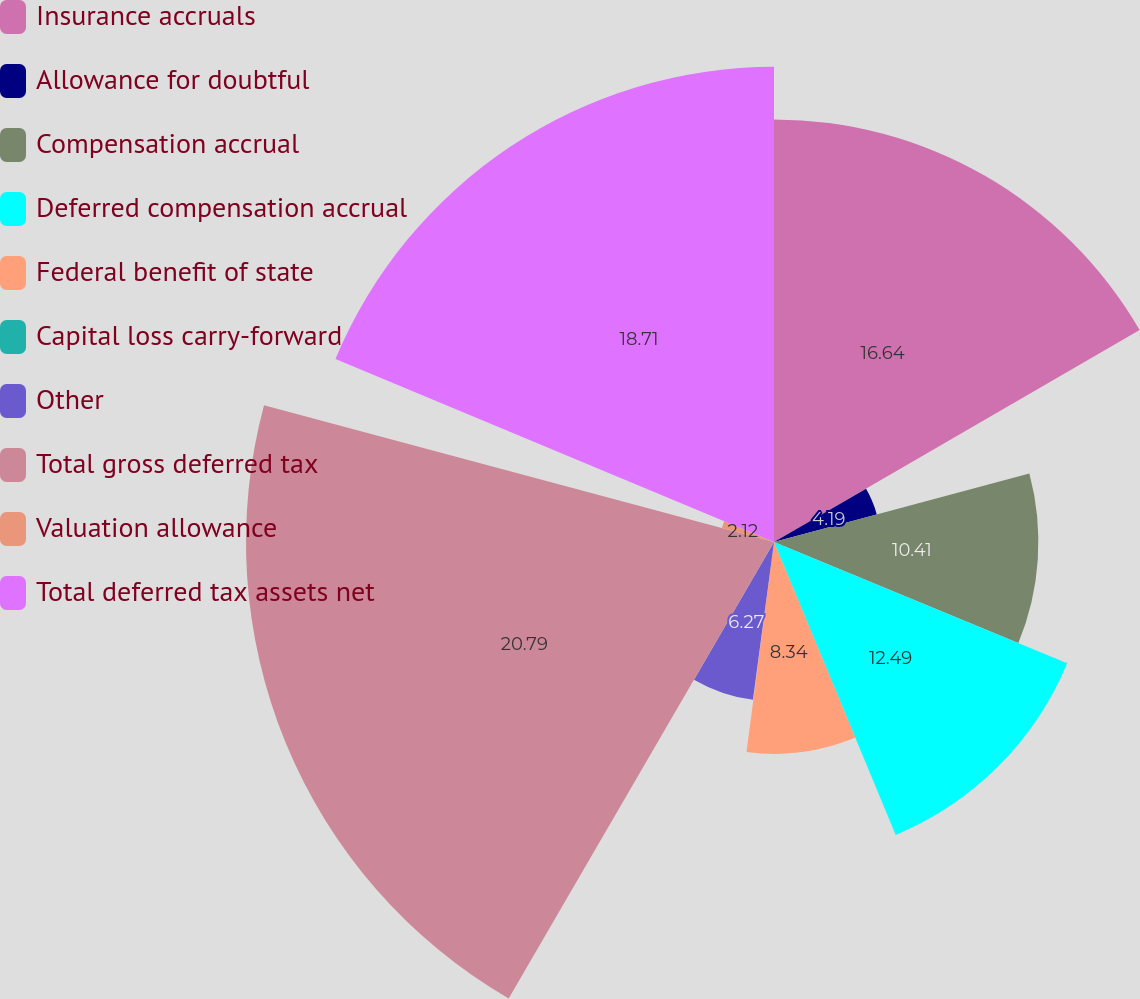Convert chart. <chart><loc_0><loc_0><loc_500><loc_500><pie_chart><fcel>Insurance accruals<fcel>Allowance for doubtful<fcel>Compensation accrual<fcel>Deferred compensation accrual<fcel>Federal benefit of state<fcel>Capital loss carry-forward<fcel>Other<fcel>Total gross deferred tax<fcel>Valuation allowance<fcel>Total deferred tax assets net<nl><fcel>16.64%<fcel>4.19%<fcel>10.41%<fcel>12.49%<fcel>8.34%<fcel>0.04%<fcel>6.27%<fcel>20.79%<fcel>2.12%<fcel>18.71%<nl></chart> 